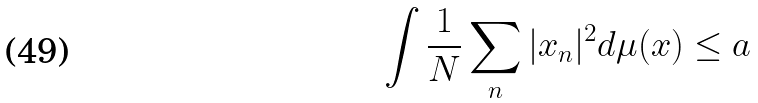Convert formula to latex. <formula><loc_0><loc_0><loc_500><loc_500>\int \frac { 1 } { N } \sum _ { n } | x _ { n } | ^ { 2 } d \mu ( x ) \leq a</formula> 